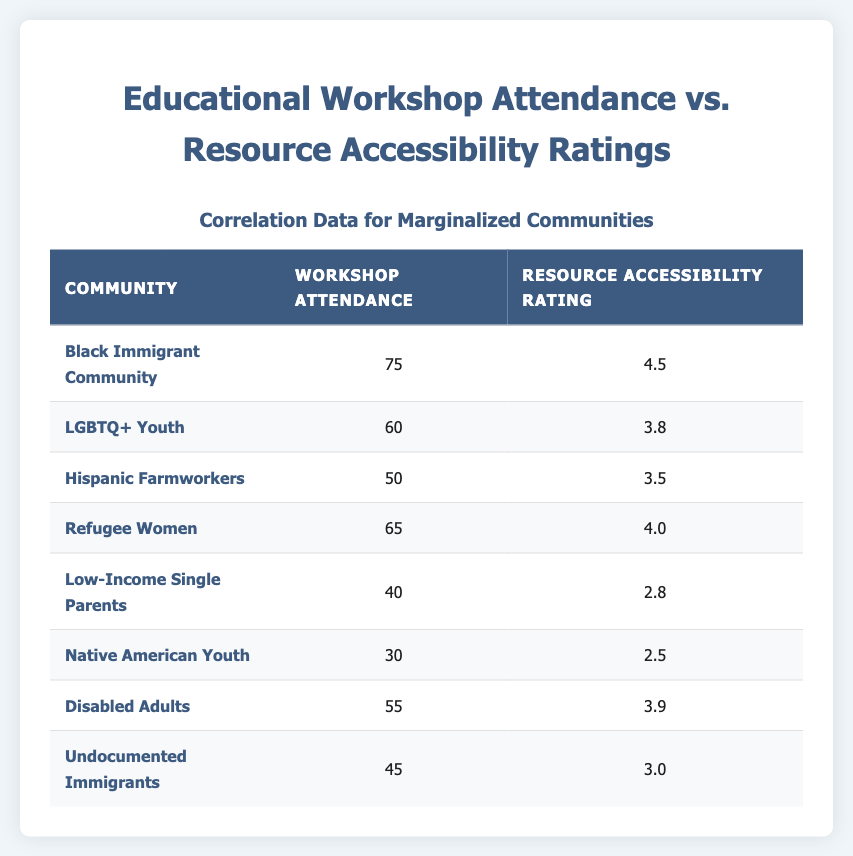What is the resource accessibility rating for the Disabled Adults community? The table lists the resource accessibility rating as 3.9 for the Disabled Adults community.
Answer: 3.9 Which community has the highest workshop attendance? The Black Immigrant Community has the highest workshop attendance at 75.
Answer: Black Immigrant Community What is the average workshop attendance across all communities? Adding all workshop attendance values (75 + 60 + 50 + 65 + 40 + 30 + 55 + 45) equals 420. Since there are 8 communities, the average is 420 / 8 = 52.5.
Answer: 52.5 Is the resource accessibility rating for Low-Income Single Parents greater than 3.0? The resource accessibility rating for Low-Income Single Parents is 2.8, which is not greater than 3.0.
Answer: No Which community has the lowest resource accessibility rating, and what is that rating? The Native American Youth community has the lowest resource accessibility rating at 2.5.
Answer: Native American Youth, 2.5 What is the difference in workshop attendance between the Black Immigrant Community and the Native American Youth? The Black Immigrant Community has 75 in workshop attendance, while the Native American Youth has 30. The difference is 75 - 30 = 45.
Answer: 45 Are there more communities with a resource accessibility rating above 3.5 than below it? There are five communities with ratings above 3.5 (Black Immigrant Community, Refugee Women, Disabled Adults, LGBTQ+ Youth, and Hispanic Farmworkers) and three communities with ratings below 3.5 (Low-Income Single Parents, Native American Youth, and Undocumented Immigrants). So yes, there are more communities above 3.5.
Answer: Yes What is the resource accessibility rating for the LGBTQ+ Youth community, and how does it compare to that of the Refugee Women? The resource accessibility rating for LGBTQ+ Youth is 3.8, while for Refugee Women, it is 4.0. Therefore, Refugee Women have a higher rating by 0.2.
Answer: 3.8, lower by 0.2 How many communities have workshop attendance ratings of 50 or higher? The communities with 50 or higher workshop attendance are: Black Immigrant Community (75), LGBTQ+ Youth (60), Refugee Women (65), and Disabled Adults (55). That accounts for 4 communities.
Answer: 4 